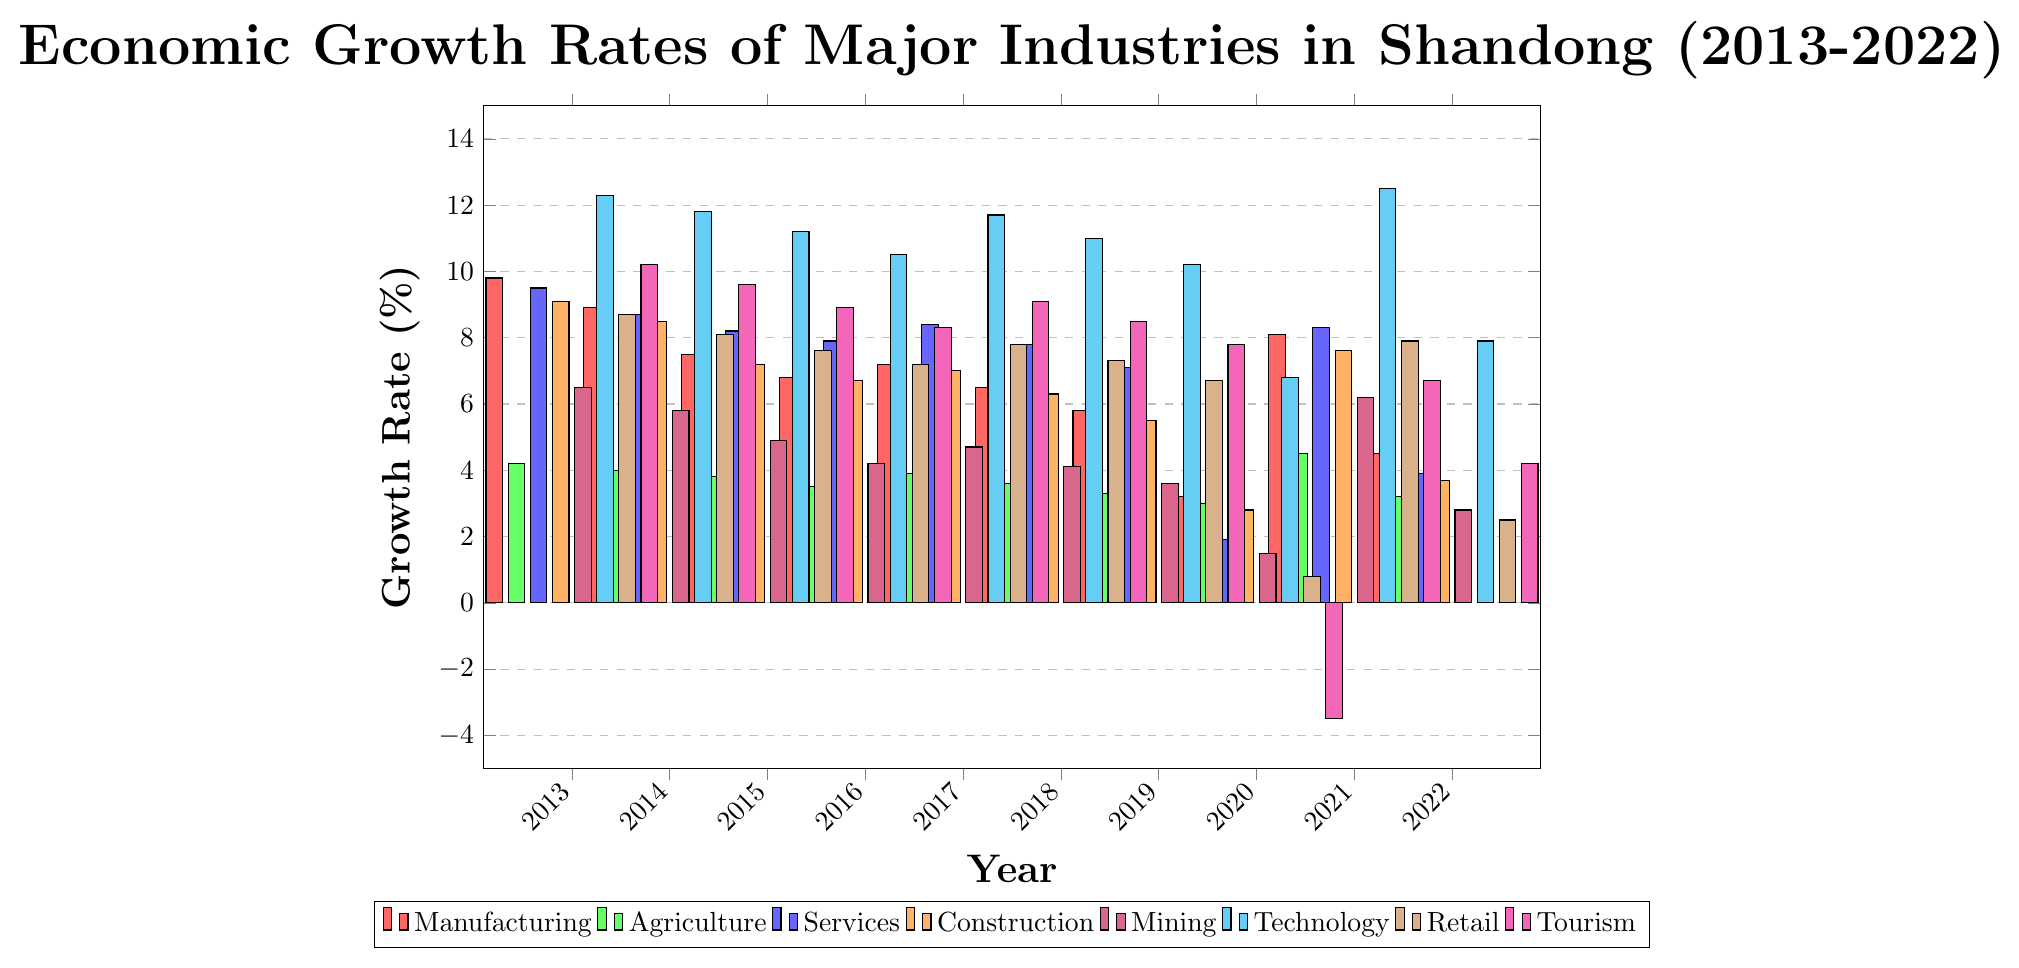Which industry had the highest growth rate in 2022? The bar for Technology in 2022 is the tallest among all the industries.
Answer: Technology Compare the growth rates of Manufacturing and Construction industries in 2016. Which one is higher? The bar heights show that in 2016, Manufacturing had a growth rate of 6.8% compared to Construction's 6.7%.
Answer: Manufacturing Between Technology and Retail, which industry experienced a negative growth rate in 2020? The bar for Retail in 2020 is much lower, showing a significant drop to 0.8%, whereas Technology had a positive growth rate of 6.8%.
Answer: Retail What is the average growth rate of the Manufacturing industry from 2019 to 2022? Sum of the growth rates from 2019 to 2022 is (5.8 + 3.2 + 8.1 + 4.5) = 21.6. The average is 21.6 / 4 = 5.4%.
Answer: 5.4% Which industry had the largest drop in growth rate from 2019 to 2020? By comparing the bars from 2019 to 2020, Tourism shows the largest drop from 7.8% to -3.5%.
Answer: Tourism In what year did the Services industry experience the lowest growth rate? Observing the bars for Services, the lowest point is in the year 2020 with a rate of 1.9%.
Answer: 2020 What is the difference in growth rate between Agriculture and Services industries in 2017? The growth rate for Agriculture in 2017 is 3.9% and for Services is 8.4%. The difference is 8.4 - 3.9 = 4.5%.
Answer: 4.5% How many times did the Mining industry have a growth rate below 5% in the decade? Mining has growth rates below 5% in the years 2015, 2016, 2018, 2019, 2020, and 2022, totaling 6 times.
Answer: 6 Does the Technology industry maintain a consistently higher growth rate than Manufacturing throughout the decade? Comparing the bars for each year, Technology consistently has higher growth rates than Manufacturing from 2013 to 2022.
Answer: Yes What is the overall trend for the growth rate in the Construction industry from 2013 to 2022? The bars for Construction generally show a declining trend from 9.1% in 2013 to 3.7% in 2022.
Answer: Declining 